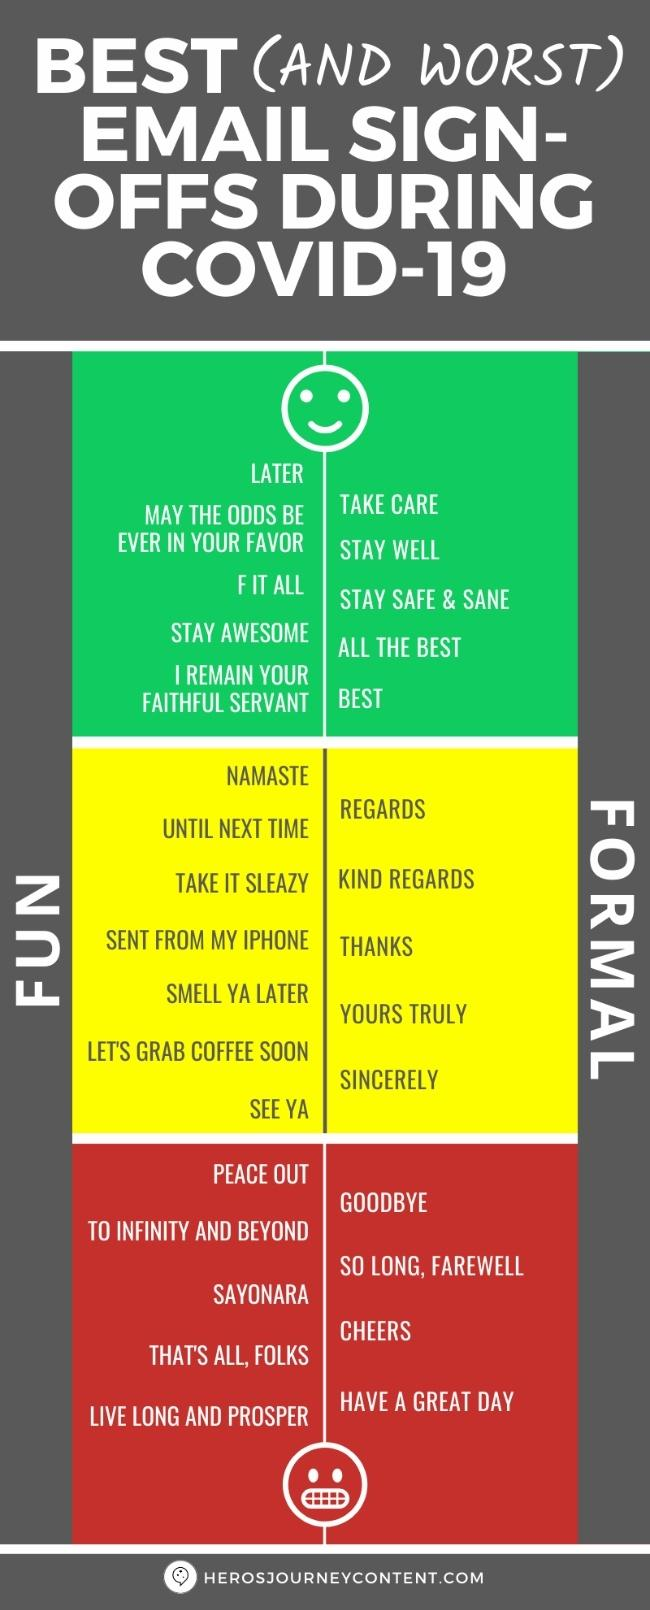Draw attention to some important aspects in this diagram. Regards, namaste, sincerely, and thanks are not under the "Formal" category. Cheers, stay awesome, I remain or see ya? cheers is not under the "Fun" category. 